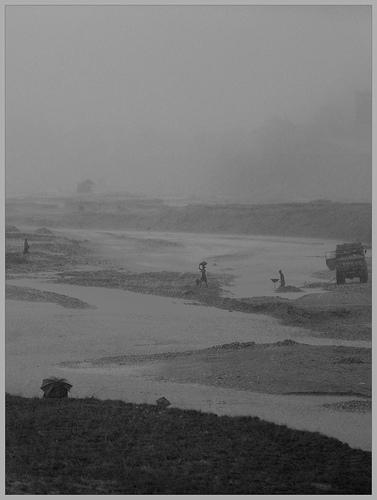How many trucks are pictured?
Give a very brief answer. 1. How many animals are shown?
Give a very brief answer. 0. How many benches are photographed?
Give a very brief answer. 0. How many zebras are eating?
Give a very brief answer. 0. 